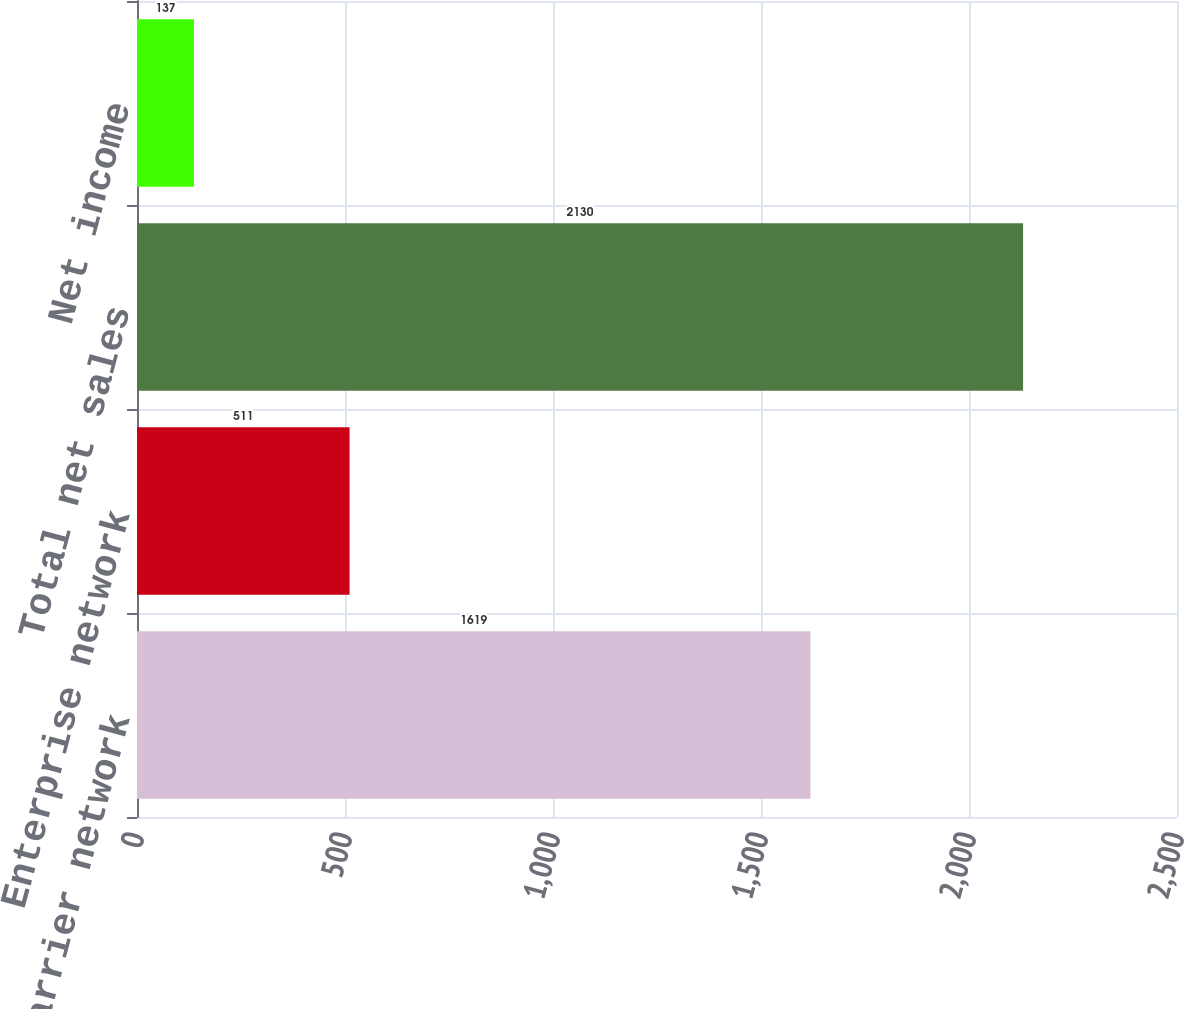Convert chart. <chart><loc_0><loc_0><loc_500><loc_500><bar_chart><fcel>Carrier network<fcel>Enterprise network<fcel>Total net sales<fcel>Net income<nl><fcel>1619<fcel>511<fcel>2130<fcel>137<nl></chart> 